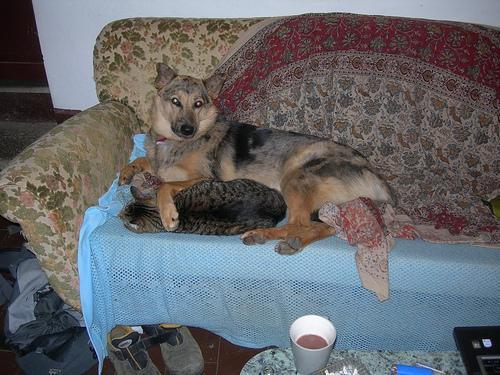How many people are wearing hat?
Give a very brief answer. 0. 